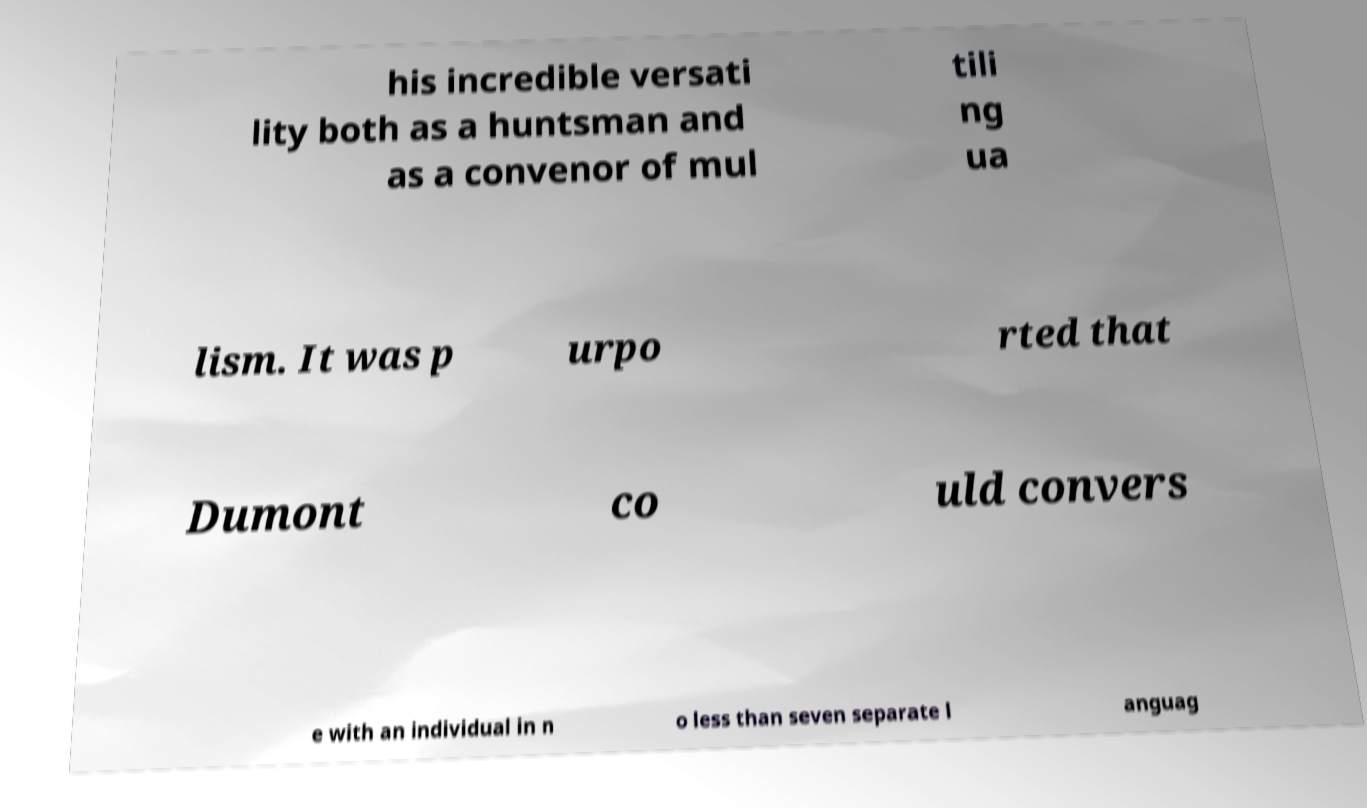Can you accurately transcribe the text from the provided image for me? his incredible versati lity both as a huntsman and as a convenor of mul tili ng ua lism. It was p urpo rted that Dumont co uld convers e with an individual in n o less than seven separate l anguag 